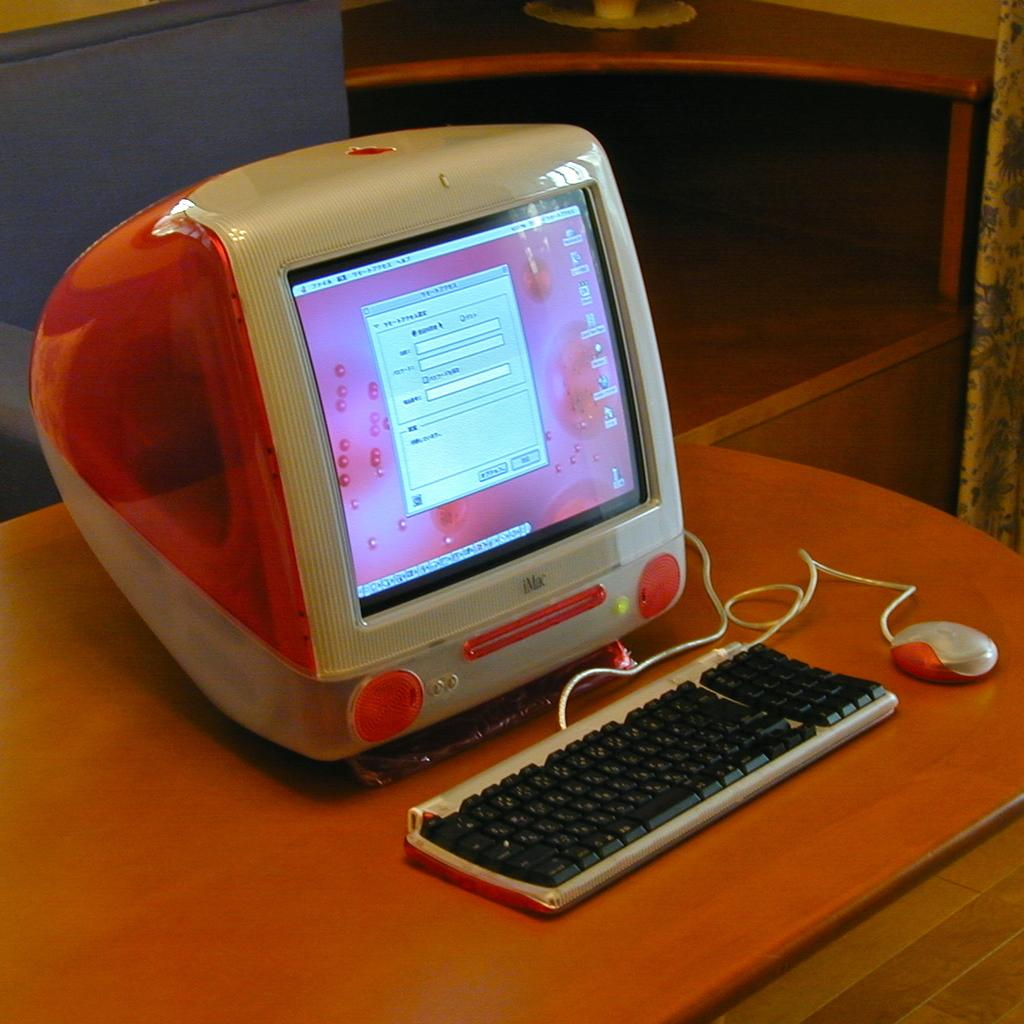What is the main object in the image? There is a computer system in the image. Where is the computer system located? The computer system is on a table. What else can be seen near the table in the image? There is a curtain beside the table in the image. What type of prison is depicted in the image? There is no prison present in the image; it features a computer system on a table with a curtain beside it. How many pairs of trousers can be seen hanging from the curtain in the image? There are no trousers present in the image; only a computer system, a table, and a curtain are visible. 